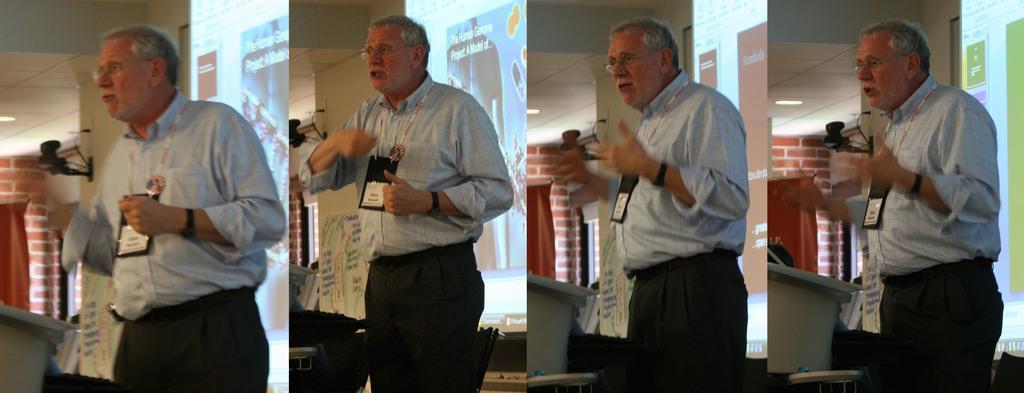Please provide a concise description of this image. This is a collage image of a person wearing a Id card. 